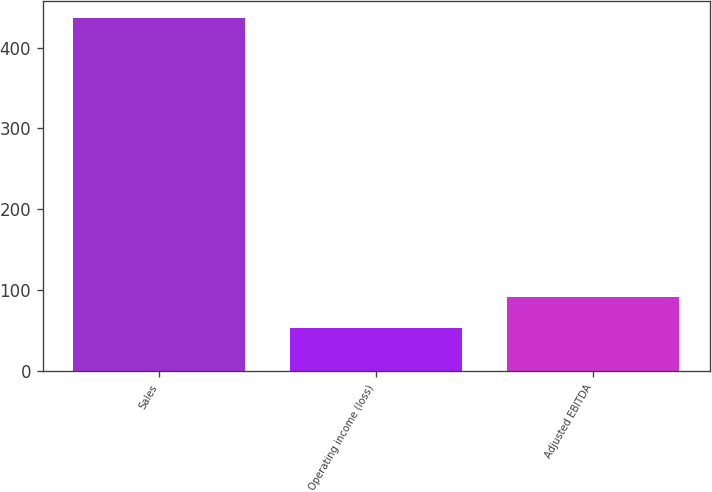<chart> <loc_0><loc_0><loc_500><loc_500><bar_chart><fcel>Sales<fcel>Operating income (loss)<fcel>Adjusted EBITDA<nl><fcel>436.1<fcel>53.9<fcel>92.12<nl></chart> 